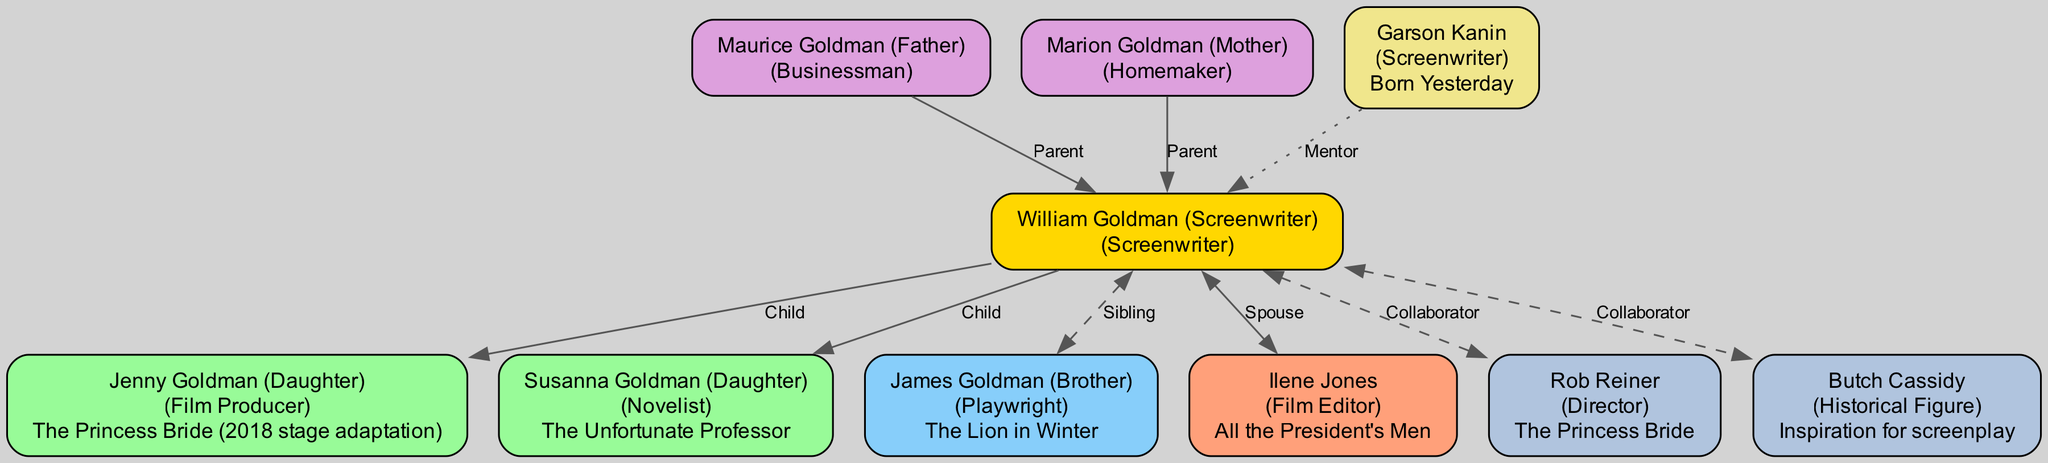What is the profession of William Goldman? The diagram identifies William Goldman as a "Screenwriter." This information is located in the root node of the family tree.
Answer: Screenwriter How many children does William Goldman have? Referring to the children section of the diagram, there are two nodes listed under children. This leads to the conclusion that he has two children.
Answer: 2 What notable work is associated with Jenny Goldman? The node representing Jenny Goldman directly indicates her notable work as "The Princess Bride (2018 stage adaptation)." This information is visually connected to her node on the diagram.
Answer: The Princess Bride (2018 stage adaptation) Who is William Goldman's spouse? By examining the spouse node of the diagram, it clearly identifies "Ilene Jones" as his spouse. This is indicated by a connecting edge labeled "Spouse."
Answer: Ilene Jones Which profession is related to James Goldman? The sibling node for James Goldman specifies that his profession is "Playwright," which can be found in his corresponding node in the family tree.
Answer: Playwright What is the notable work of Garson Kanin? In the mentors section, the node for Garson Kanin specifies his notable work as "Born Yesterday," which can be traced back to his relationship as a mentor to William Goldman.
Answer: Born Yesterday Who collaborated with William Goldman on "The Princess Bride"? The collaborator node lists Rob Reiner, whose profession is labeled as "Director." This is also noted as a significant collaborative relationship concerning the film "The Princess Bride."
Answer: Rob Reiner What familial relationship does Susanna Goldman have with William Goldman? Susanna Goldman is identified under the children section of the diagram, and since she is listed there, she is established as a daughter of William Goldman.
Answer: Daughter Which parent of William Goldman is noted as a homemaker? Within the parents section, Marion Goldman is specifically described with the profession "Homemaker," making it clear that she is the one associated with that role.
Answer: Marion Goldman 